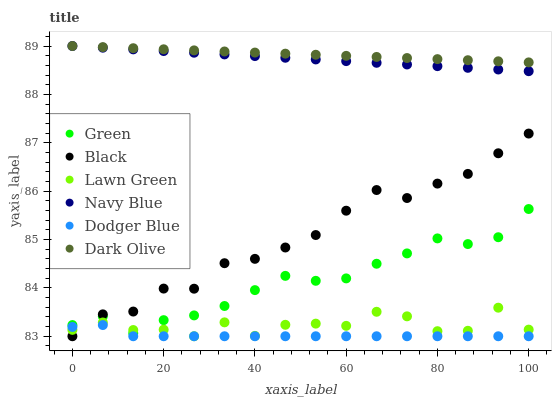Does Dodger Blue have the minimum area under the curve?
Answer yes or no. Yes. Does Dark Olive have the maximum area under the curve?
Answer yes or no. Yes. Does Navy Blue have the minimum area under the curve?
Answer yes or no. No. Does Navy Blue have the maximum area under the curve?
Answer yes or no. No. Is Navy Blue the smoothest?
Answer yes or no. Yes. Is Lawn Green the roughest?
Answer yes or no. Yes. Is Dark Olive the smoothest?
Answer yes or no. No. Is Dark Olive the roughest?
Answer yes or no. No. Does Lawn Green have the lowest value?
Answer yes or no. Yes. Does Navy Blue have the lowest value?
Answer yes or no. No. Does Dark Olive have the highest value?
Answer yes or no. Yes. Does Dodger Blue have the highest value?
Answer yes or no. No. Is Black less than Navy Blue?
Answer yes or no. Yes. Is Navy Blue greater than Lawn Green?
Answer yes or no. Yes. Does Navy Blue intersect Dark Olive?
Answer yes or no. Yes. Is Navy Blue less than Dark Olive?
Answer yes or no. No. Is Navy Blue greater than Dark Olive?
Answer yes or no. No. Does Black intersect Navy Blue?
Answer yes or no. No. 